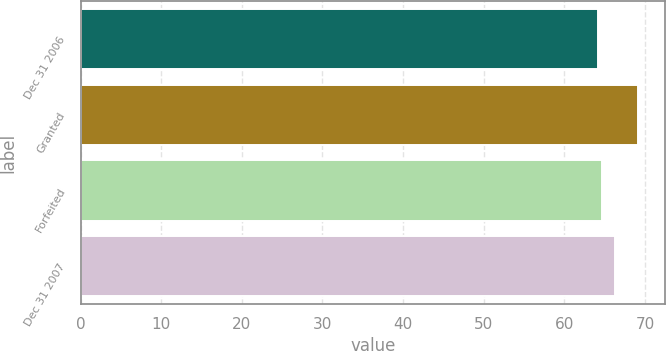Convert chart. <chart><loc_0><loc_0><loc_500><loc_500><bar_chart><fcel>Dec 31 2006<fcel>Granted<fcel>Forfeited<fcel>Dec 31 2007<nl><fcel>64.15<fcel>69.08<fcel>64.64<fcel>66.31<nl></chart> 